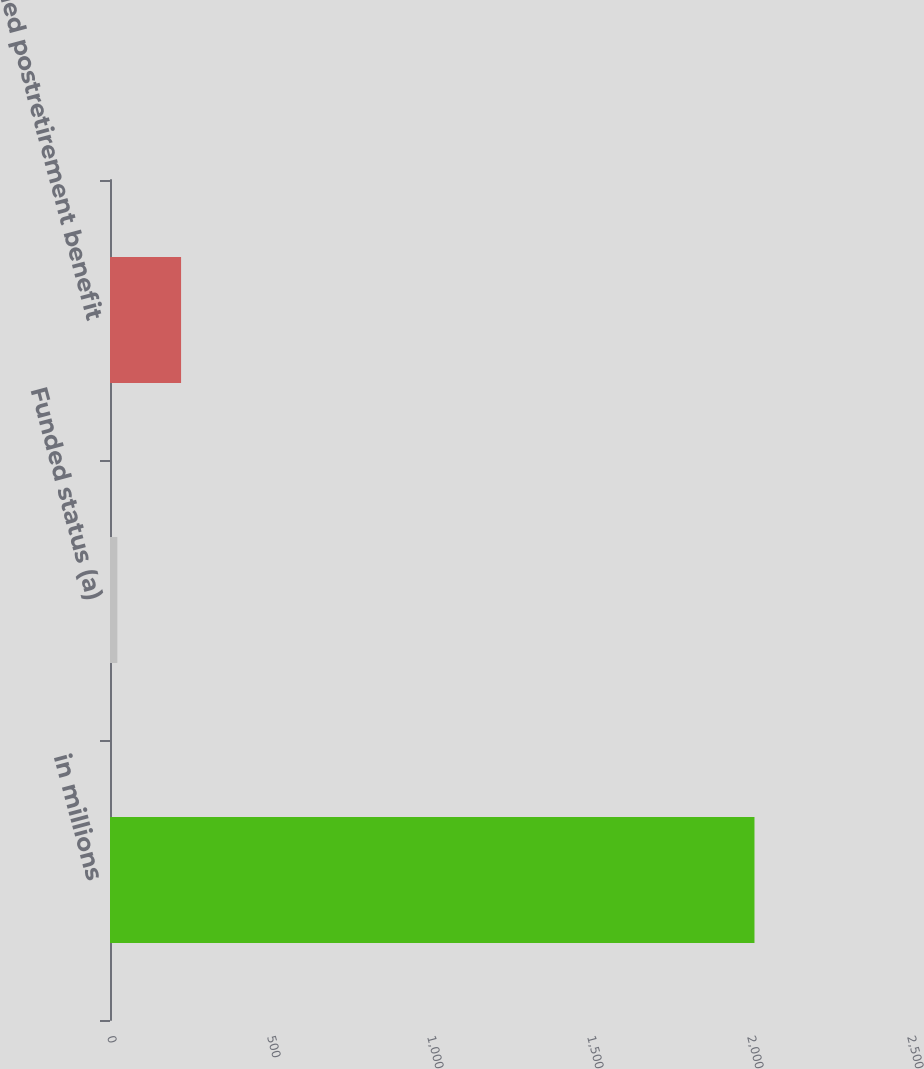<chart> <loc_0><loc_0><loc_500><loc_500><bar_chart><fcel>in millions<fcel>Funded status (a)<fcel>Accrued postretirement benefit<nl><fcel>2014<fcel>23<fcel>222.1<nl></chart> 